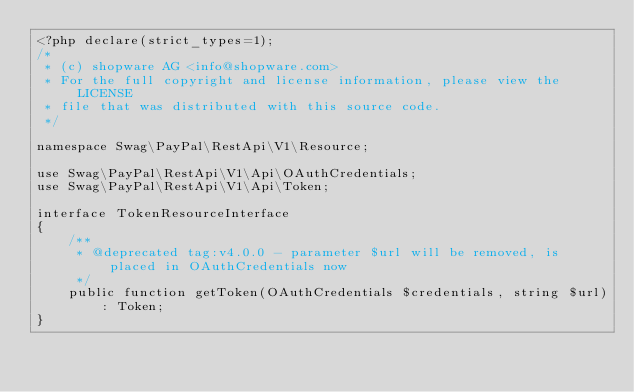Convert code to text. <code><loc_0><loc_0><loc_500><loc_500><_PHP_><?php declare(strict_types=1);
/*
 * (c) shopware AG <info@shopware.com>
 * For the full copyright and license information, please view the LICENSE
 * file that was distributed with this source code.
 */

namespace Swag\PayPal\RestApi\V1\Resource;

use Swag\PayPal\RestApi\V1\Api\OAuthCredentials;
use Swag\PayPal\RestApi\V1\Api\Token;

interface TokenResourceInterface
{
    /**
     * @deprecated tag:v4.0.0 - parameter $url will be removed, is placed in OAuthCredentials now
     */
    public function getToken(OAuthCredentials $credentials, string $url): Token;
}
</code> 